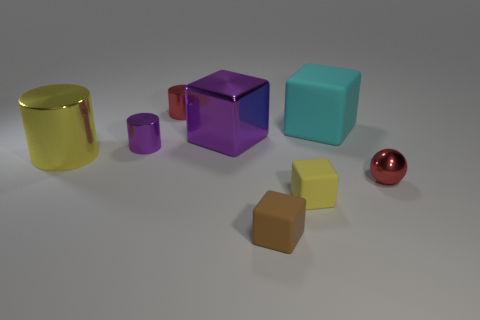How many other things are the same color as the tiny ball?
Offer a terse response. 1. What size is the purple metal object that is the same shape as the tiny yellow matte thing?
Provide a succinct answer. Large. There is a big thing that is left of the large cyan matte object and to the right of the large yellow metallic object; what material is it?
Keep it short and to the point. Metal. Is the color of the tiny cube to the left of the small yellow block the same as the big rubber object?
Provide a short and direct response. No. Is the color of the small metallic ball the same as the large shiny object that is behind the yellow metal cylinder?
Your response must be concise. No. There is a large cyan rubber thing; are there any big purple metal cubes behind it?
Your answer should be very brief. No. Is the big cylinder made of the same material as the large cyan cube?
Ensure brevity in your answer.  No. There is a purple thing that is the same size as the metal ball; what is its material?
Offer a terse response. Metal. What number of objects are either purple metallic things in front of the metallic cube or large metal objects?
Provide a short and direct response. 3. Is the number of large rubber blocks that are in front of the tiny red cylinder the same as the number of red objects?
Your answer should be very brief. No. 